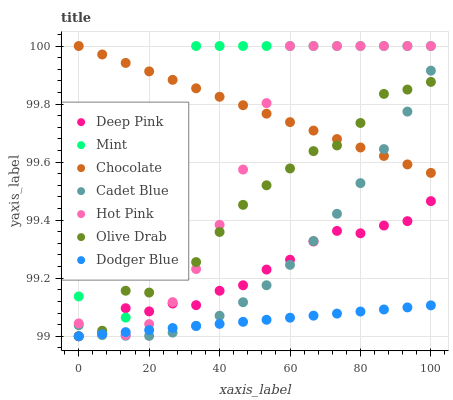Does Dodger Blue have the minimum area under the curve?
Answer yes or no. Yes. Does Mint have the maximum area under the curve?
Answer yes or no. Yes. Does Hot Pink have the minimum area under the curve?
Answer yes or no. No. Does Hot Pink have the maximum area under the curve?
Answer yes or no. No. Is Chocolate the smoothest?
Answer yes or no. Yes. Is Mint the roughest?
Answer yes or no. Yes. Is Hot Pink the smoothest?
Answer yes or no. No. Is Hot Pink the roughest?
Answer yes or no. No. Does Deep Pink have the lowest value?
Answer yes or no. Yes. Does Hot Pink have the lowest value?
Answer yes or no. No. Does Mint have the highest value?
Answer yes or no. Yes. Does Deep Pink have the highest value?
Answer yes or no. No. Is Deep Pink less than Chocolate?
Answer yes or no. Yes. Is Chocolate greater than Deep Pink?
Answer yes or no. Yes. Does Hot Pink intersect Dodger Blue?
Answer yes or no. Yes. Is Hot Pink less than Dodger Blue?
Answer yes or no. No. Is Hot Pink greater than Dodger Blue?
Answer yes or no. No. Does Deep Pink intersect Chocolate?
Answer yes or no. No. 